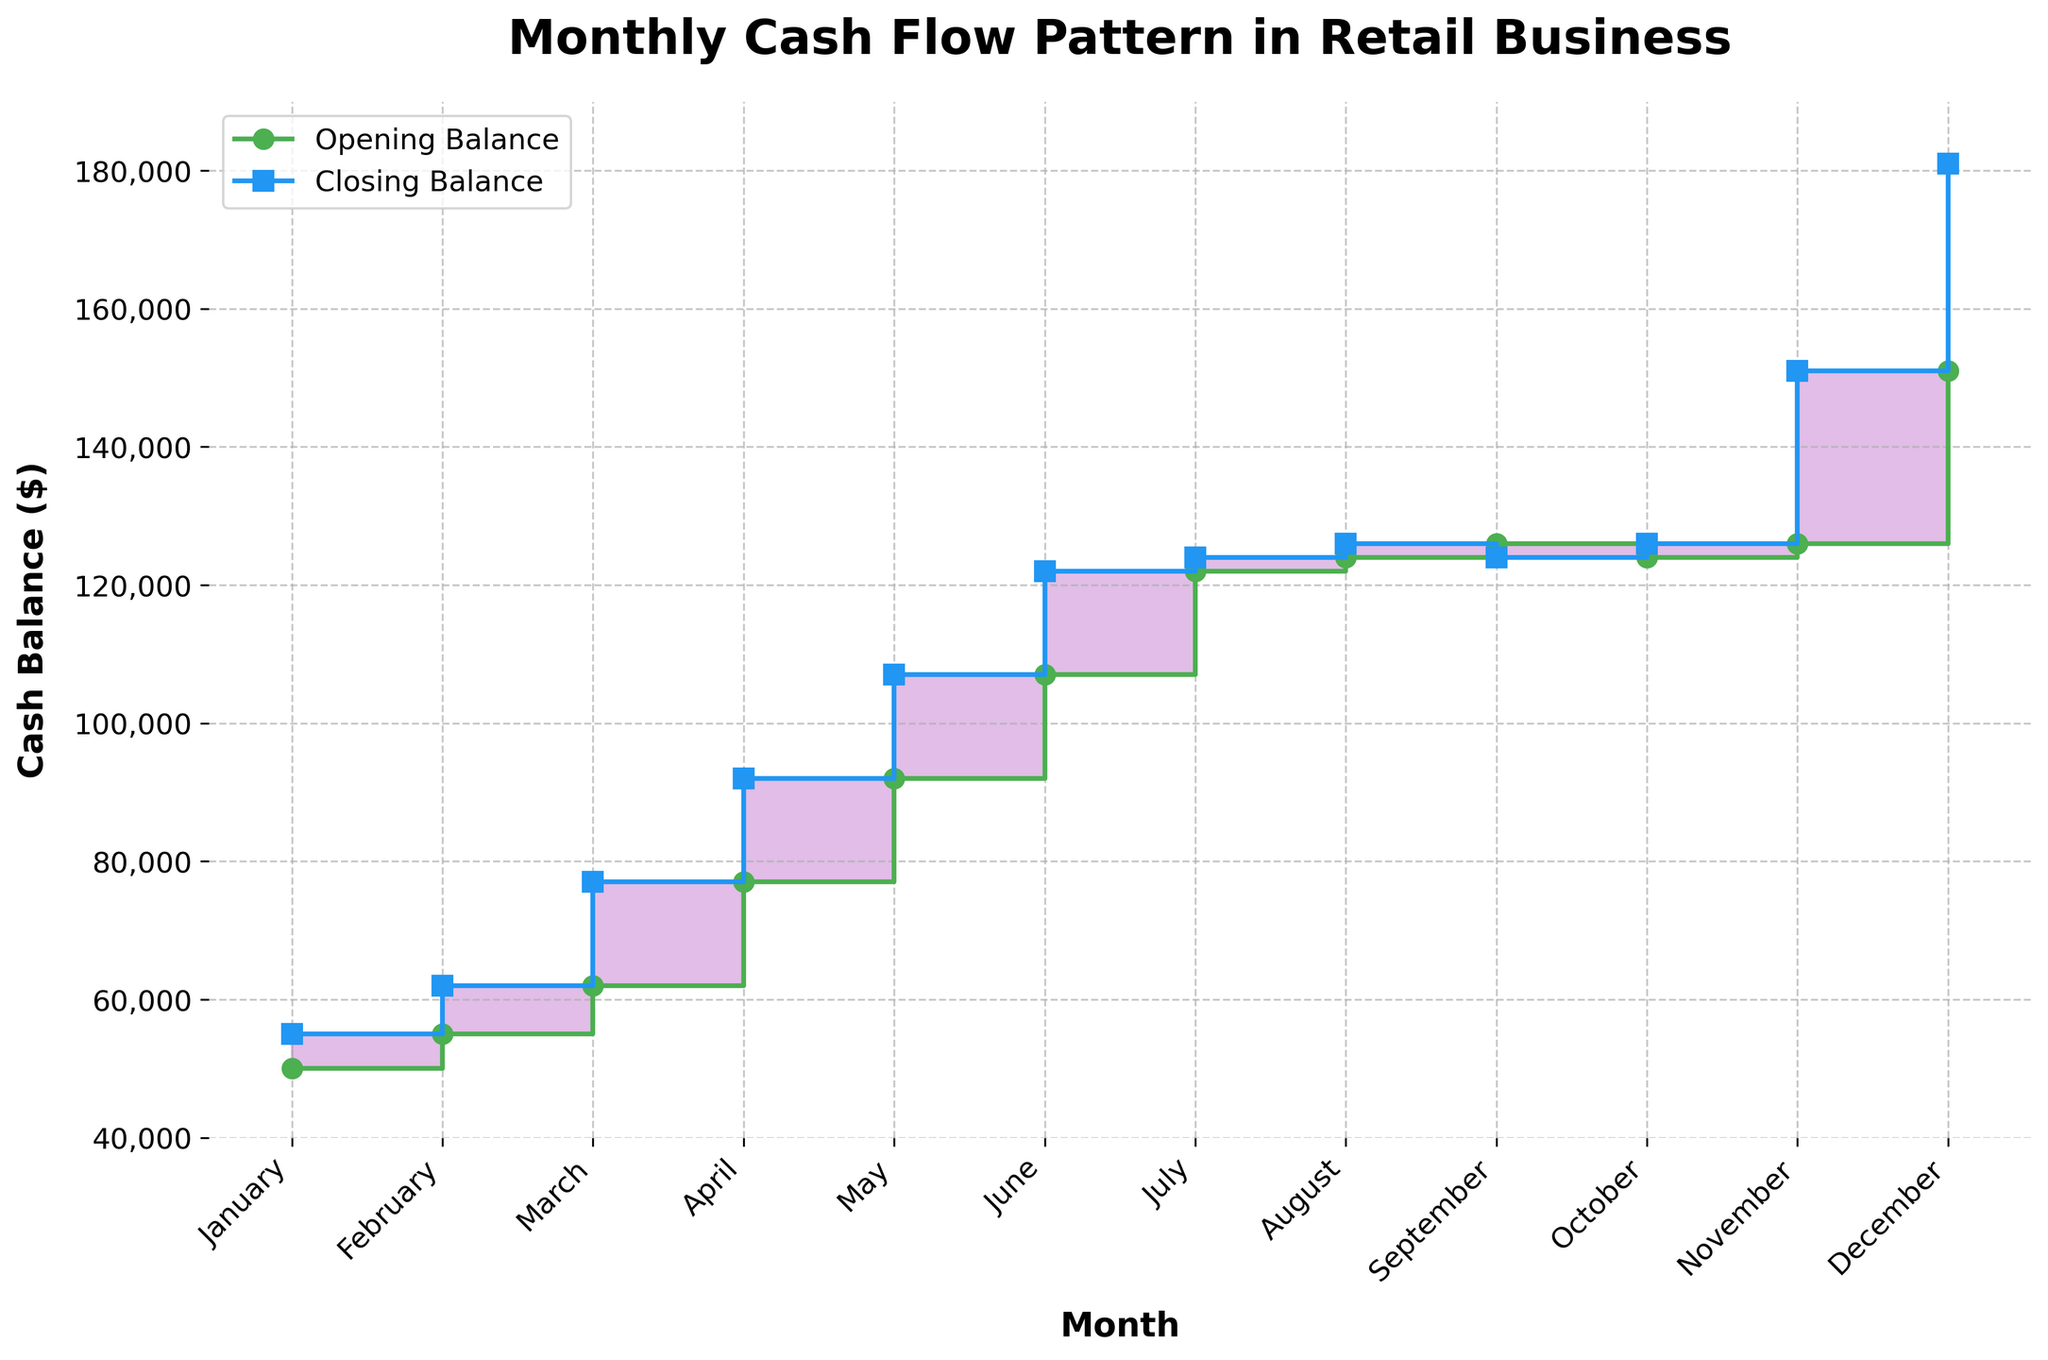What is the title of the figure? The title of the figure is typically found at the top and provides a summary of what the chart is about. Here, it is "Monthly Cash Flow Pattern in Retail Business".
Answer: Monthly Cash Flow Pattern in Retail Business What are the labels for the x-axis and y-axis? The x-axis label describes the horizontal data (months) and the y-axis label describes the vertical data (cash balance in dollars). The x-axis label is "Month" and the y-axis label is "Cash Balance ($)".
Answer: Month, Cash Balance ($) What color represents the Opening Balance? The figure uses distinct colors for different elements. The Opening Balance is represented by a green line.
Answer: Green During which month does the Closing Balance reach its highest? To determine this, we look at the highest point of the blue (Closing Balance) line. This occurs in December.
Answer: December What is the difference between the Opening and Closing Balance in November? To find this, subtract the Opening Balance of November from the Closing Balance of November: 151,000 - 126,000 = 25,000.
Answer: 25,000 How does the Opening Balance in April compare with that in March? Compare the green markers for these two months. The Opening Balance in April (77,000) is higher than in March (62,000).
Answer: Higher Which month has the smallest gap between Opening and Closing Balance, and what is the amount? To find this, we look for the smallest difference between the green (Opening Balance) and blue (Closing Balance) lines for each month. The smallest gap is in September, with a gap of 2,000 (126,000 - 124,000 = 2,000).
Answer: September, 2,000 Calculate the average Sales over the entire year. Add all the monthly Sales values and divide by 12: (80,000 + 85,000 + 95,000 + 100,000 + 105,000 + 110,000 + 95,000 + 90,000 + 85,000 + 95,000 + 120,000 + 130,000) / 12 = 99,167.
Answer: 99,167 What is the total Expenses for the year? Sum up all monthly expenses: 75,000 + 78,000 + 80,000 + 85,000 + 90,000 + 95,000 + 93,000 + 88,000 + 87,000 + 93,000 + 95,000 + 100,000 = 1,059,000.
Answer: 1,059,000 Overall, does the Closing Balance show an increasing or decreasing trend over the year? Observing the blue line from January to December, it consistently increases, indicating an overall increasing trend.
Answer: Increasing 